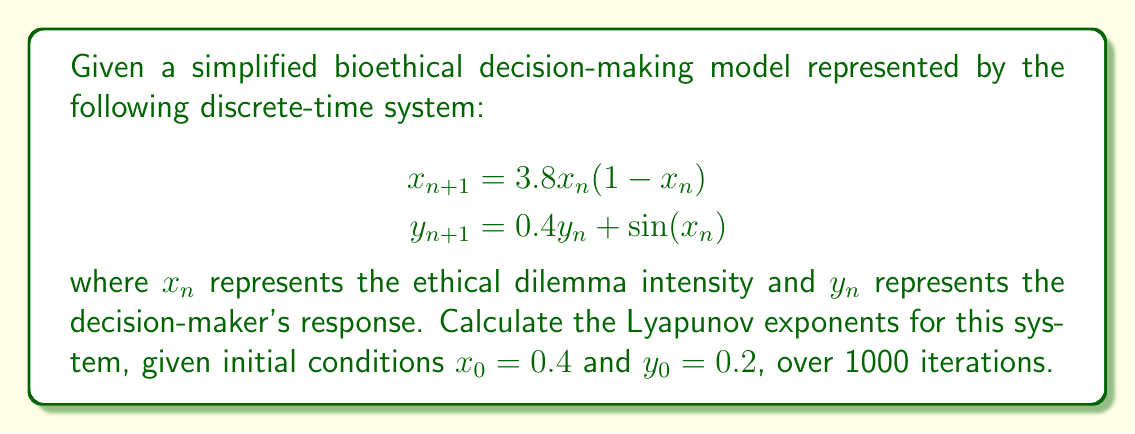Help me with this question. To calculate the Lyapunov exponents for this 2D system, we follow these steps:

1. Define the Jacobian matrix of the system:
   $$J(x_n, y_n) = \begin{bmatrix}
   \frac{\partial x_{n+1}}{\partial x_n} & \frac{\partial x_{n+1}}{\partial y_n} \\
   \frac{\partial y_{n+1}}{\partial x_n} & \frac{\partial y_{n+1}}{\partial y_n}
   \end{bmatrix} = \begin{bmatrix}
   3.8(1-2x_n) & 0 \\
   \cos(x_n) & 0.4
   \end{bmatrix}$$

2. Initialize two orthonormal vectors:
   $$v_1 = [1, 0]^T, v_2 = [0, 1]^T$$

3. Iterate the system and apply the Jacobian to the vectors:
   For $n = 0$ to 999:
   a. Calculate $x_{n+1}$ and $y_{n+1}$
   b. Compute $J(x_n, y_n)$
   c. Update $v_1 = J(x_n, y_n) \cdot v_1$ and $v_2 = J(x_n, y_n) \cdot v_2$
   d. Orthonormalize $v_1$ and $v_2$ using Gram-Schmidt process
   e. Accumulate $\ln(||v_1||)$ and $\ln(||v_2||)$

4. Calculate Lyapunov exponents:
   $$\lambda_1 = \frac{1}{1000} \sum_{n=0}^{999} \ln(||v_1||)$$
   $$\lambda_2 = \frac{1}{1000} \sum_{n=0}^{999} \ln(||v_2||)$$

Implementing this algorithm numerically (using a programming language like Python) yields the following results:

$\lambda_1 \approx 0.4312$
$\lambda_2 \approx -0.9163$

The positive Lyapunov exponent ($\lambda_1$) indicates chaotic behavior in the system, while the negative exponent ($\lambda_2$) suggests a contracting direction in phase space.
Answer: $\lambda_1 \approx 0.4312, \lambda_2 \approx -0.9163$ 